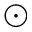Convert formula to latex. <formula><loc_0><loc_0><loc_500><loc_500>\odot</formula> 